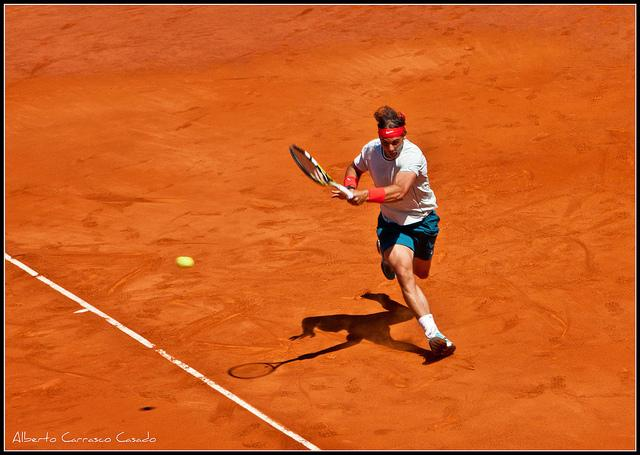Upon what surfaced court is this game being played? clay 